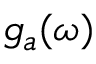<formula> <loc_0><loc_0><loc_500><loc_500>g _ { a } ( \omega )</formula> 